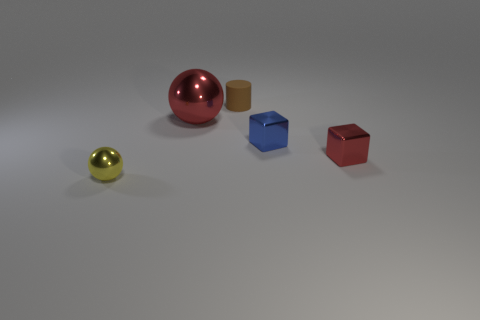Add 1 blue metal things. How many objects exist? 6 Subtract all balls. How many objects are left? 3 Subtract all cyan matte blocks. Subtract all cylinders. How many objects are left? 4 Add 5 tiny blue cubes. How many tiny blue cubes are left? 6 Add 3 brown cubes. How many brown cubes exist? 3 Subtract 0 gray cylinders. How many objects are left? 5 